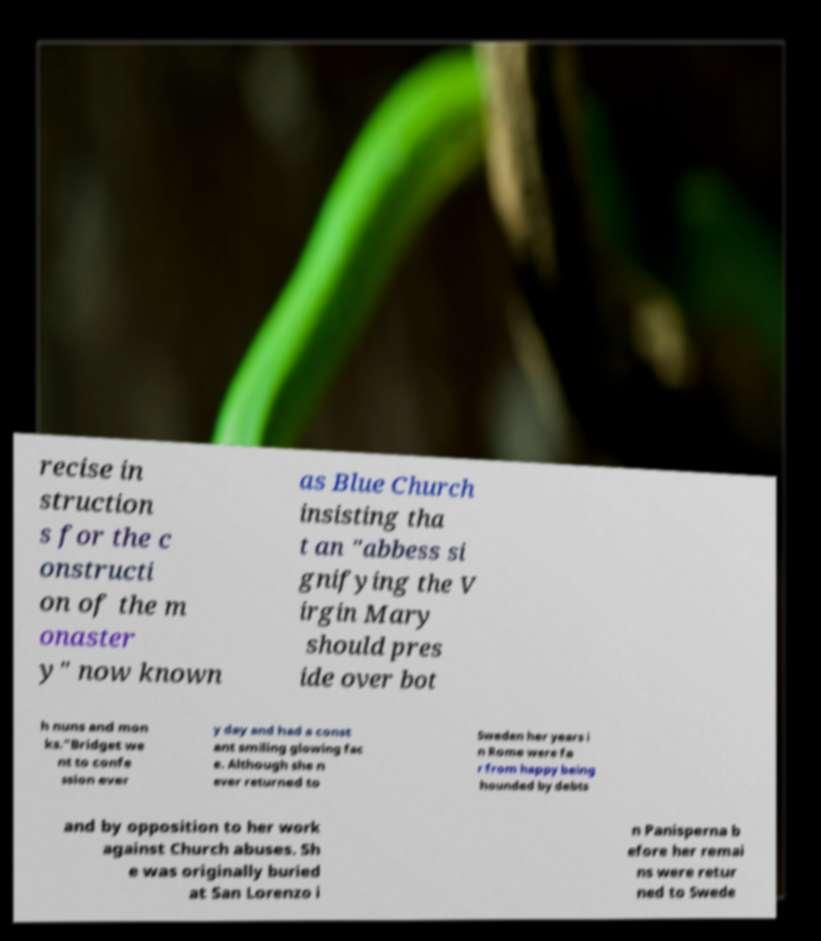Can you accurately transcribe the text from the provided image for me? recise in struction s for the c onstructi on of the m onaster y" now known as Blue Church insisting tha t an "abbess si gnifying the V irgin Mary should pres ide over bot h nuns and mon ks."Bridget we nt to confe ssion ever y day and had a const ant smiling glowing fac e. Although she n ever returned to Sweden her years i n Rome were fa r from happy being hounded by debts and by opposition to her work against Church abuses. Sh e was originally buried at San Lorenzo i n Panisperna b efore her remai ns were retur ned to Swede 